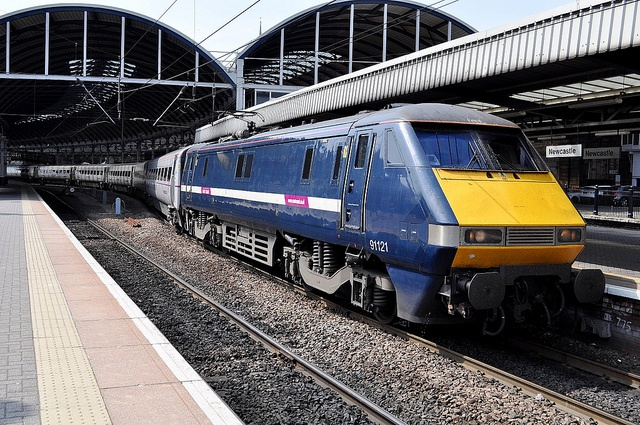Describe the objects in this image and their specific colors. I can see train in white, black, darkgray, gray, and navy tones, car in white, black, gray, and darkblue tones, and car in white, black, and gray tones in this image. 